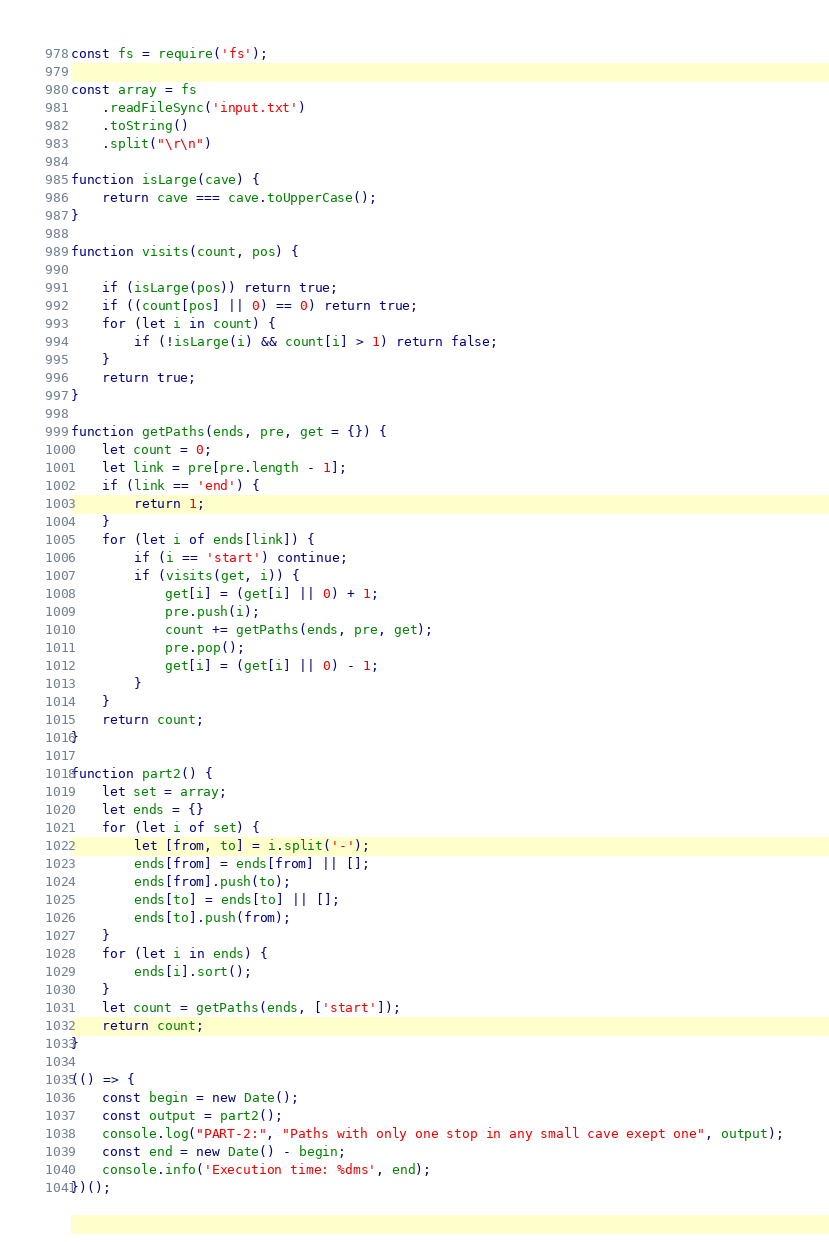<code> <loc_0><loc_0><loc_500><loc_500><_JavaScript_>const fs = require('fs');

const array = fs
    .readFileSync('input.txt')
    .toString()
    .split("\r\n")

function isLarge(cave) {
    return cave === cave.toUpperCase();
}

function visits(count, pos) {

    if (isLarge(pos)) return true;
    if ((count[pos] || 0) == 0) return true;
    for (let i in count) {
        if (!isLarge(i) && count[i] > 1) return false;
    }
    return true;
}

function getPaths(ends, pre, get = {}) {
    let count = 0;
    let link = pre[pre.length - 1];
    if (link == 'end') {
        return 1;
    }
    for (let i of ends[link]) {
        if (i == 'start') continue;
        if (visits(get, i)) {
            get[i] = (get[i] || 0) + 1;
            pre.push(i);
            count += getPaths(ends, pre, get);
            pre.pop();
            get[i] = (get[i] || 0) - 1;
        }
    }
    return count;
}

function part2() {
    let set = array;
    let ends = {}
    for (let i of set) {
        let [from, to] = i.split('-');
        ends[from] = ends[from] || [];
        ends[from].push(to);
        ends[to] = ends[to] || [];
        ends[to].push(from);
    }
    for (let i in ends) {
        ends[i].sort();
    }
    let count = getPaths(ends, ['start']);
    return count;
}

(() => {
    const begin = new Date();
    const output = part2();
    console.log("PART-2:", "Paths with only one stop in any small cave exept one", output);
    const end = new Date() - begin;
    console.info('Execution time: %dms', end);
})();</code> 